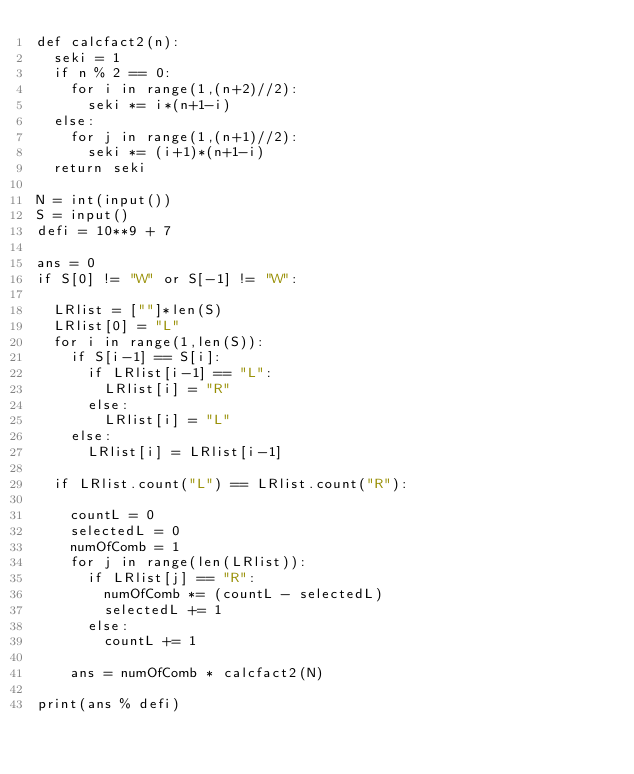Convert code to text. <code><loc_0><loc_0><loc_500><loc_500><_Python_>def calcfact2(n):
  seki = 1
  if n % 2 == 0:
    for i in range(1,(n+2)//2):
      seki *= i*(n+1-i)
  else:
    for j in range(1,(n+1)//2):
      seki *= (i+1)*(n+1-i)
  return seki

N = int(input())
S = input()
defi = 10**9 + 7

ans = 0
if S[0] != "W" or S[-1] != "W":

  LRlist = [""]*len(S)
  LRlist[0] = "L"
  for i in range(1,len(S)):
    if S[i-1] == S[i]:
      if LRlist[i-1] == "L":
        LRlist[i] = "R"
      else:
        LRlist[i] = "L"
    else:
      LRlist[i] = LRlist[i-1]
      
  if LRlist.count("L") == LRlist.count("R"):

    countL = 0
    selectedL = 0
    numOfComb = 1
    for j in range(len(LRlist)):
      if LRlist[j] == "R":
        numOfComb *= (countL - selectedL)
        selectedL += 1
      else:
        countL += 1

    ans = numOfComb * calcfact2(N)
    
print(ans % defi)</code> 